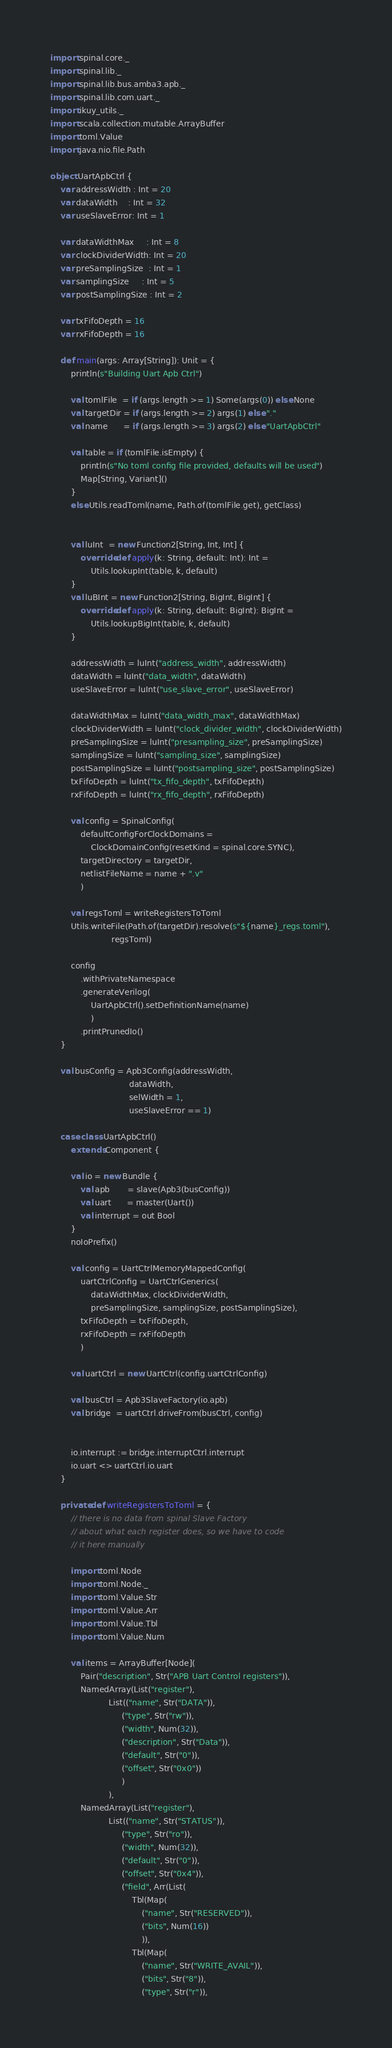Convert code to text. <code><loc_0><loc_0><loc_500><loc_500><_Scala_>import spinal.core._
import spinal.lib._
import spinal.lib.bus.amba3.apb._
import spinal.lib.com.uart._
import ikuy_utils._
import scala.collection.mutable.ArrayBuffer
import toml.Value
import java.nio.file.Path

object UartApbCtrl {
	var addressWidth : Int = 20
	var dataWidth    : Int = 32
	var useSlaveError: Int = 1

	var dataWidthMax     : Int = 8
	var clockDividerWidth: Int = 20
	var preSamplingSize  : Int = 1
	var samplingSize     : Int = 5
	var postSamplingSize : Int = 2

	var txFifoDepth = 16
	var rxFifoDepth = 16

	def main(args: Array[String]): Unit = {
		println(s"Building Uart Apb Ctrl")

		val tomlFile  = if (args.length >= 1) Some(args(0)) else None
		val targetDir = if (args.length >= 2) args(1) else "."
		val name      = if (args.length >= 3) args(2) else "UartApbCtrl"

		val table = if (tomlFile.isEmpty) {
			println(s"No toml config file provided, defaults will be used")
			Map[String, Variant]()
		}
		else Utils.readToml(name, Path.of(tomlFile.get), getClass)


		val luInt  = new Function2[String, Int, Int] {
			override def apply(k: String, default: Int): Int =
				Utils.lookupInt(table, k, default)
		}
		val luBInt = new Function2[String, BigInt, BigInt] {
			override def apply(k: String, default: BigInt): BigInt =
				Utils.lookupBigInt(table, k, default)
		}

		addressWidth = luInt("address_width", addressWidth)
		dataWidth = luInt("data_width", dataWidth)
		useSlaveError = luInt("use_slave_error", useSlaveError)

		dataWidthMax = luInt("data_width_max", dataWidthMax)
		clockDividerWidth = luInt("clock_divider_width", clockDividerWidth)
		preSamplingSize = luInt("presampling_size", preSamplingSize)
		samplingSize = luInt("sampling_size", samplingSize)
		postSamplingSize = luInt("postsampling_size", postSamplingSize)
		txFifoDepth = luInt("tx_fifo_depth", txFifoDepth)
		rxFifoDepth = luInt("rx_fifo_depth", rxFifoDepth)

		val config = SpinalConfig(
			defaultConfigForClockDomains =
				ClockDomainConfig(resetKind = spinal.core.SYNC),
			targetDirectory = targetDir,
			netlistFileName = name + ".v"
			)

		val regsToml = writeRegistersToToml
		Utils.writeFile(Path.of(targetDir).resolve(s"${name}_regs.toml"),
		                regsToml)

		config
			.withPrivateNamespace
			.generateVerilog(
				UartApbCtrl().setDefinitionName(name)
				)
			.printPrunedIo()
	}

	val busConfig = Apb3Config(addressWidth,
	                           dataWidth,
	                           selWidth = 1,
	                           useSlaveError == 1)

	case class UartApbCtrl()
		extends Component {

		val io = new Bundle {
			val apb       = slave(Apb3(busConfig))
			val uart      = master(Uart())
			val interrupt = out Bool
		}
		noIoPrefix()

		val config = UartCtrlMemoryMappedConfig(
			uartCtrlConfig = UartCtrlGenerics(
				dataWidthMax, clockDividerWidth,
				preSamplingSize, samplingSize, postSamplingSize),
			txFifoDepth = txFifoDepth,
			rxFifoDepth = rxFifoDepth
			)

		val uartCtrl = new UartCtrl(config.uartCtrlConfig)

		val busCtrl = Apb3SlaveFactory(io.apb)
		val bridge  = uartCtrl.driveFrom(busCtrl, config)


		io.interrupt := bridge.interruptCtrl.interrupt
		io.uart <> uartCtrl.io.uart
	}

	private def writeRegistersToToml = {
		// there is no data from spinal Slave Factory
		// about what each register does, so we have to code
		// it here manually

		import toml.Node
		import toml.Node._
		import toml.Value.Str
		import toml.Value.Arr
		import toml.Value.Tbl
		import toml.Value.Num

		val items = ArrayBuffer[Node](
			Pair("description", Str("APB Uart Control registers")),
			NamedArray(List("register"),
			           List(("name", Str("DATA")),
			                ("type", Str("rw")),
			                ("width", Num(32)),
			                ("description", Str("Data")),
			                ("default", Str("0")),
			                ("offset", Str("0x0"))
			                )
			           ),
			NamedArray(List("register"),
			           List(("name", Str("STATUS")),
			                ("type", Str("ro")),
			                ("width", Num(32)),
			                ("default", Str("0")),
			                ("offset", Str("0x4")),
			                ("field", Arr(List(
				                Tbl(Map(
					                ("name", Str("RESERVED")),
					                ("bits", Num(16))
					                )),
				                Tbl(Map(
					                ("name", Str("WRITE_AVAIL")),
					                ("bits", Str("8")),
					                ("type", Str("r")),</code> 